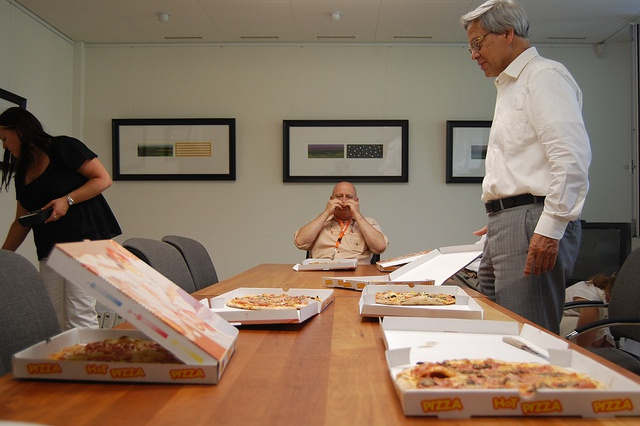Describe the objects in this image and their specific colors. I can see dining table in gray, salmon, brown, tan, and maroon tones, people in gray, darkgray, black, and lightgray tones, people in gray, black, and maroon tones, pizza in gray, tan, and salmon tones, and chair in gray and black tones in this image. 